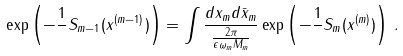Convert formula to latex. <formula><loc_0><loc_0><loc_500><loc_500>\exp \left ( - { \frac { 1 } { } } S _ { m - 1 } ( x ^ { ( m - 1 ) } ) \right ) = \int \frac { d x _ { m } d \bar { x } _ { m } } { \frac { 2 \pi } { \epsilon \omega _ { m } M _ { m } } } \exp \left ( - \frac { 1 } { } S _ { m } ( x ^ { ( m ) } ) \right ) \, .</formula> 